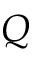<formula> <loc_0><loc_0><loc_500><loc_500>Q</formula> 